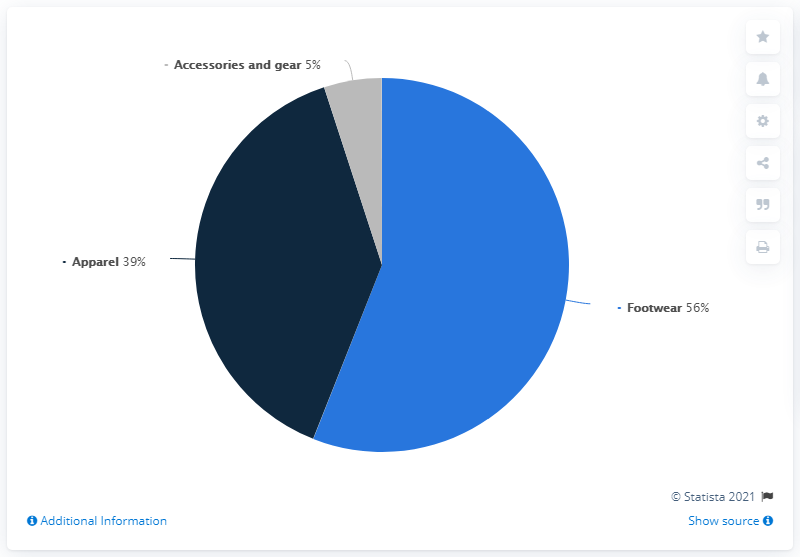Give some essential details in this illustration. Approximately 44% of sales are NOT footwear. The majority of sales are generated by footwear. 